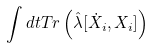<formula> <loc_0><loc_0><loc_500><loc_500>\int d t T r \left ( \hat { \lambda } [ \dot { X } _ { i } , X _ { i } ] \right )</formula> 